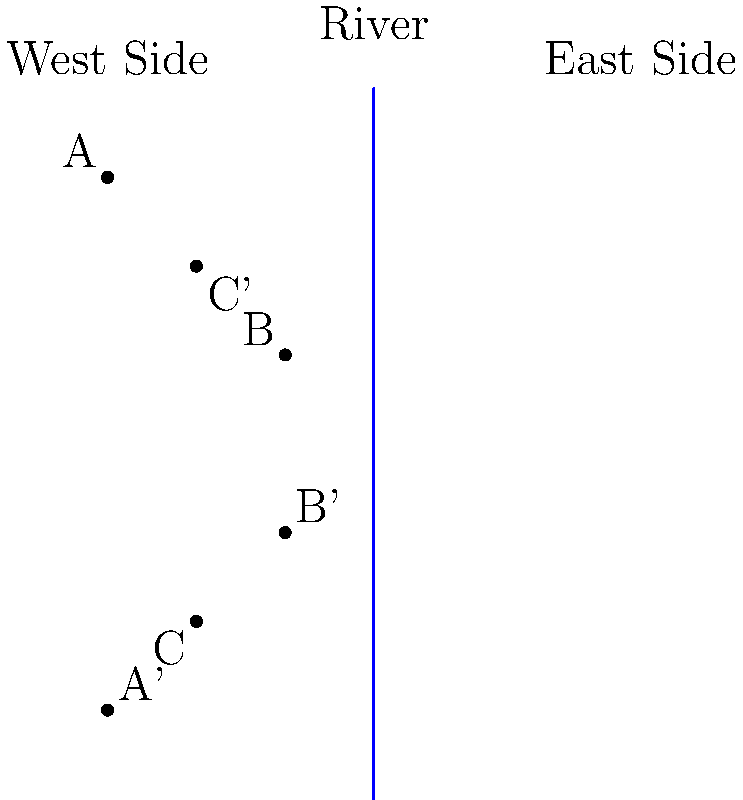As you explore the new city, you notice that it's divided by a river running north-south. The concierge provides you with a map showing three key landmarks (A, B, and C) on the west side of the river. To help you understand the layout of the east side, the concierge explains that it's a mirror image of the west side, reflected across the river. If landmark A is located at coordinates (-1.5, 1.5) on the west side, what are the coordinates of its corresponding landmark A' on the east side? To find the coordinates of landmark A' on the east side of the river, we need to reflect the coordinates of landmark A across the y-axis (which represents the river). Here's how we do it:

1. The original coordinates of A are (-1.5, 1.5).
2. In a reflection across the y-axis, the x-coordinate changes sign, while the y-coordinate remains the same.
3. So, we change -1.5 to 1.5 for the x-coordinate.
4. The y-coordinate stays as 1.5.

Therefore, the coordinates of A' after reflection are (1.5, 1.5).
Answer: (1.5, 1.5) 